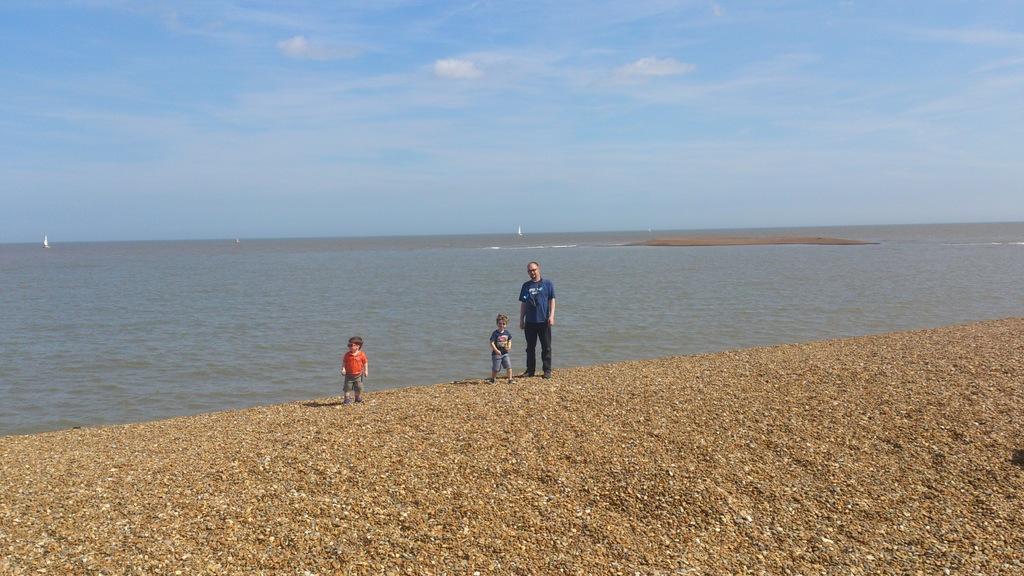In one or two sentences, can you explain what this image depicts? In the image in the center, we can see one man and two kids are standing. In the background, we can see the sky, clouds, boats and water. 